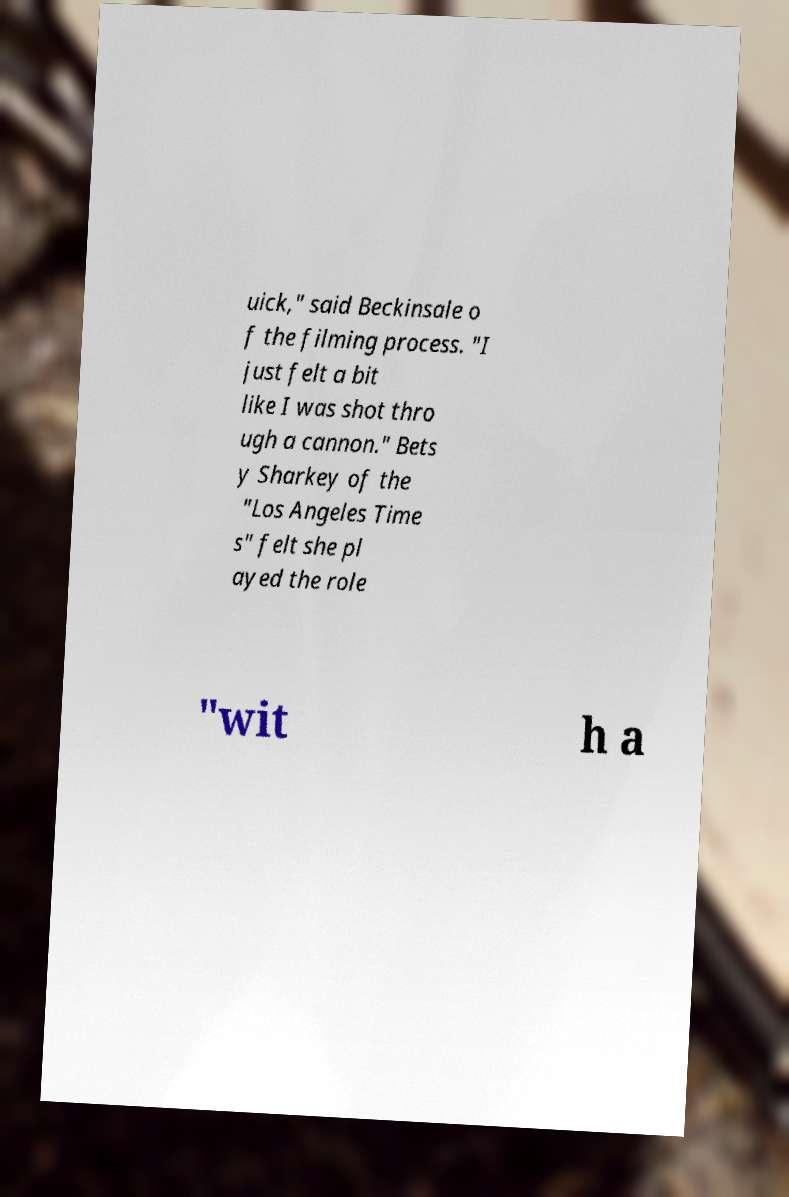Can you accurately transcribe the text from the provided image for me? uick," said Beckinsale o f the filming process. "I just felt a bit like I was shot thro ugh a cannon." Bets y Sharkey of the "Los Angeles Time s" felt she pl ayed the role "wit h a 